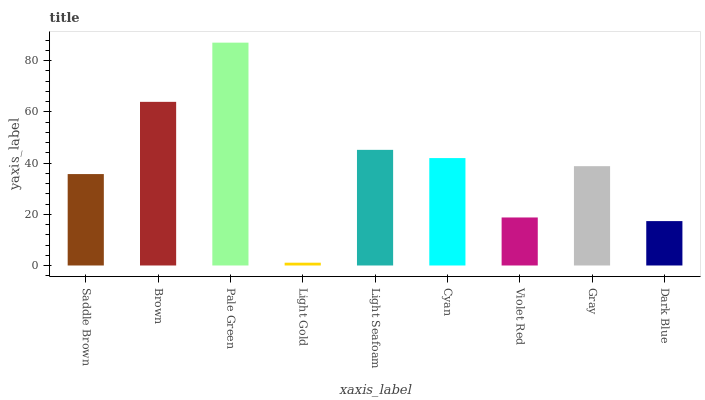Is Light Gold the minimum?
Answer yes or no. Yes. Is Pale Green the maximum?
Answer yes or no. Yes. Is Brown the minimum?
Answer yes or no. No. Is Brown the maximum?
Answer yes or no. No. Is Brown greater than Saddle Brown?
Answer yes or no. Yes. Is Saddle Brown less than Brown?
Answer yes or no. Yes. Is Saddle Brown greater than Brown?
Answer yes or no. No. Is Brown less than Saddle Brown?
Answer yes or no. No. Is Gray the high median?
Answer yes or no. Yes. Is Gray the low median?
Answer yes or no. Yes. Is Violet Red the high median?
Answer yes or no. No. Is Light Seafoam the low median?
Answer yes or no. No. 